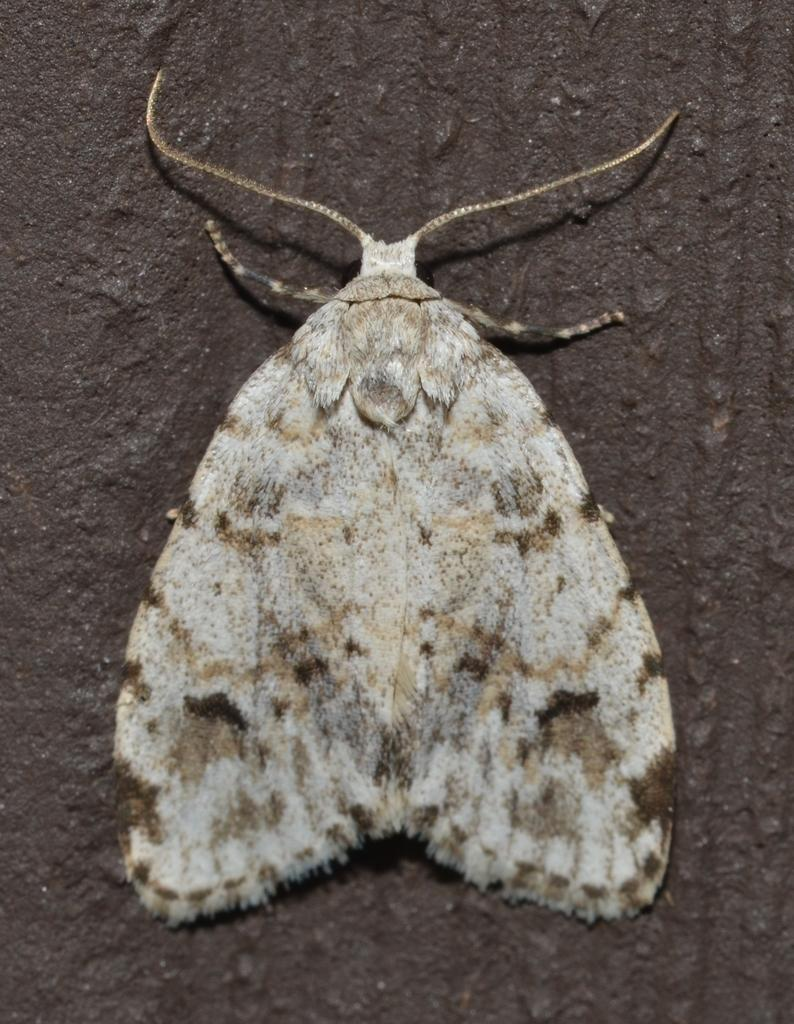What is the main subject of the image? The main subject of the image is a butterfly. Where is the butterfly located in the image? The butterfly is on a surface in the image. What type of memory is the butterfly using to navigate in the image? Butterflies do not use memory in the same way humans do; they rely on their senses and instincts for navigation. Additionally, there is no indication in the image that the butterfly is navigating or using any specific type of memory. 